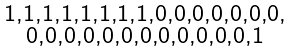Convert formula to latex. <formula><loc_0><loc_0><loc_500><loc_500>\begin{smallmatrix} 1 , 1 , 1 , 1 , 1 , 1 , 1 , 1 , 0 , 0 , 0 , 0 , 0 , 0 , 0 , \\ 0 , 0 , 0 , 0 , 0 , 0 , 0 , 0 , 0 , 0 , 0 , 0 , 1 \end{smallmatrix}</formula> 